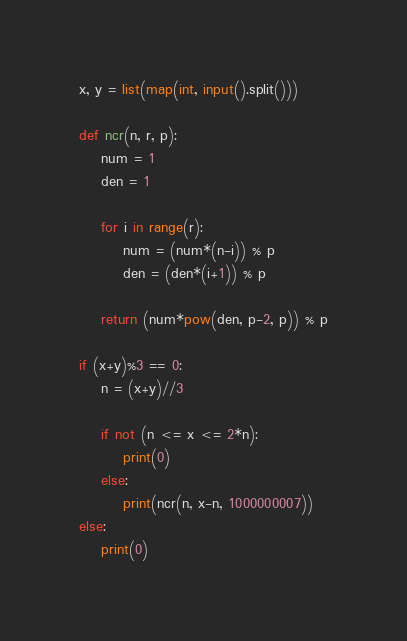Convert code to text. <code><loc_0><loc_0><loc_500><loc_500><_Python_>x, y = list(map(int, input().split()))

def ncr(n, r, p):
    num = 1
    den = 1

    for i in range(r):
        num = (num*(n-i)) % p
        den = (den*(i+1)) % p

    return (num*pow(den, p-2, p)) % p

if (x+y)%3 == 0:
    n = (x+y)//3

    if not (n <= x <= 2*n):
        print(0)
    else:
        print(ncr(n, x-n, 1000000007))
else:
    print(0)</code> 